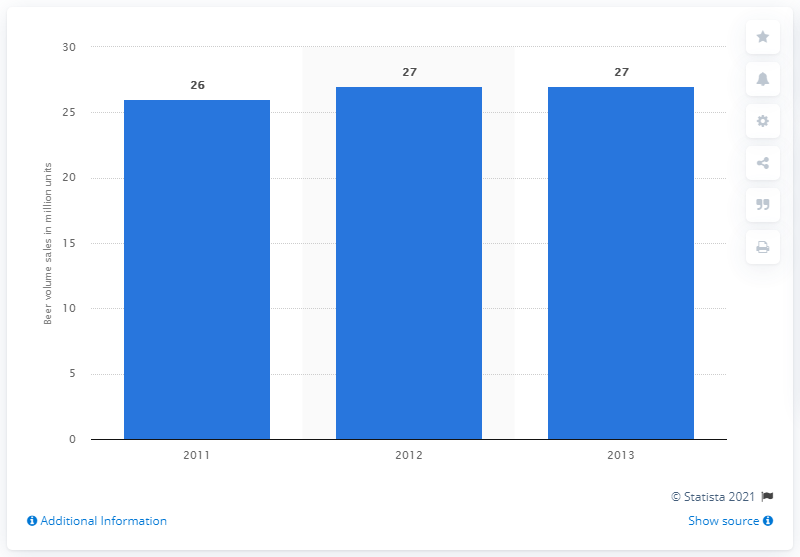List a handful of essential elements in this visual. Diageo sold 27 units of beer in 2012. 